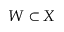<formula> <loc_0><loc_0><loc_500><loc_500>W \subset X</formula> 